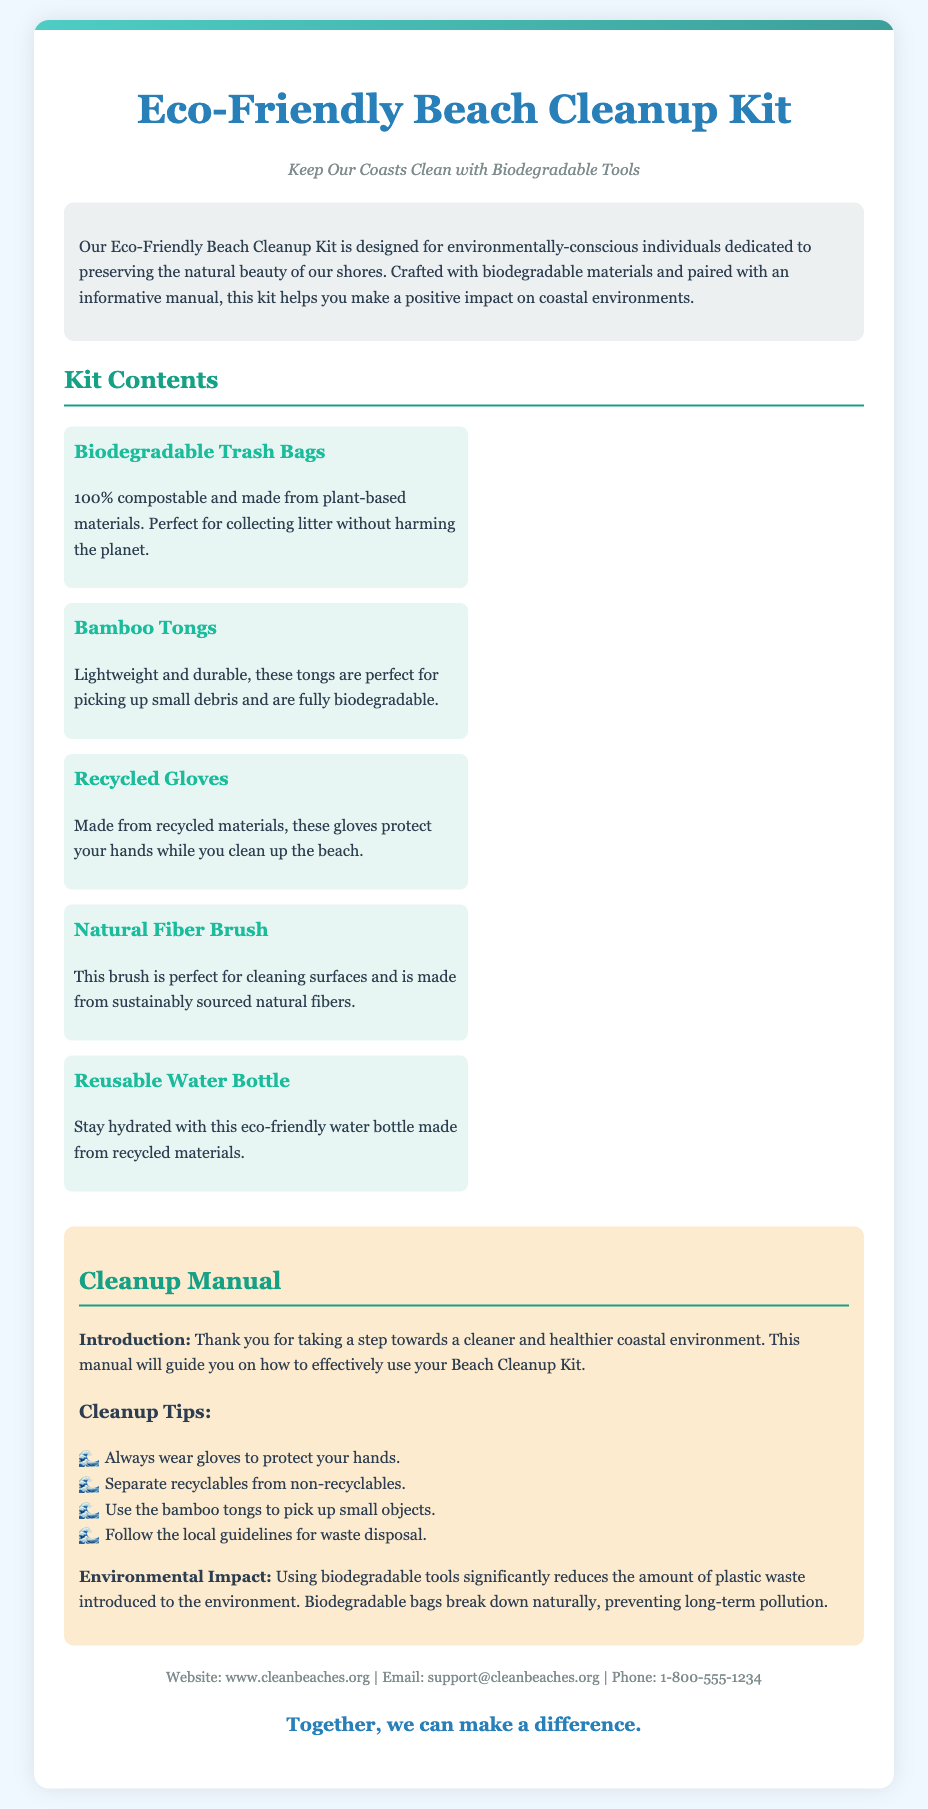What is the title of the product? The title is prominently displayed at the top of the document, identifying the product.
Answer: Eco-Friendly Beach Cleanup Kit What is the tagline associated with the kit? The tagline provides a brief statement about the product's purpose and focus.
Answer: Keep Our Coasts Clean with Biodegradable Tools What type of gloves are included in the kit? The content specifies the material used for the gloves, indicating their eco-friendliness.
Answer: Recycled Gloves How many items are listed in the kit contents? By counting the items in the kit contents, we can determine the total number of distinct tools provided.
Answer: Five What is one of the cleanup tips mentioned in the manual? The manual includes a list of recommendations for effective cleaning, one of which can be cited as an example.
Answer: Always wear gloves to protect your hands What environmental benefit is mentioned regarding biodegradable tools? The document provides information about the impact of using these specific tools on the environment.
Answer: Reduces plastic waste What material is the reusable water bottle made from? The description of the water bottle indicates its eco-friendly characteristics based on its construction material.
Answer: Recycled materials What is the phone number provided for contact? The contact information includes various ways to reach support, including a phone number.
Answer: 1-800-555-1234 What is the slogan at the end of the document? The closing slogan serves as a motivational statement about the collective impact of using the product.
Answer: Together, we can make a difference 